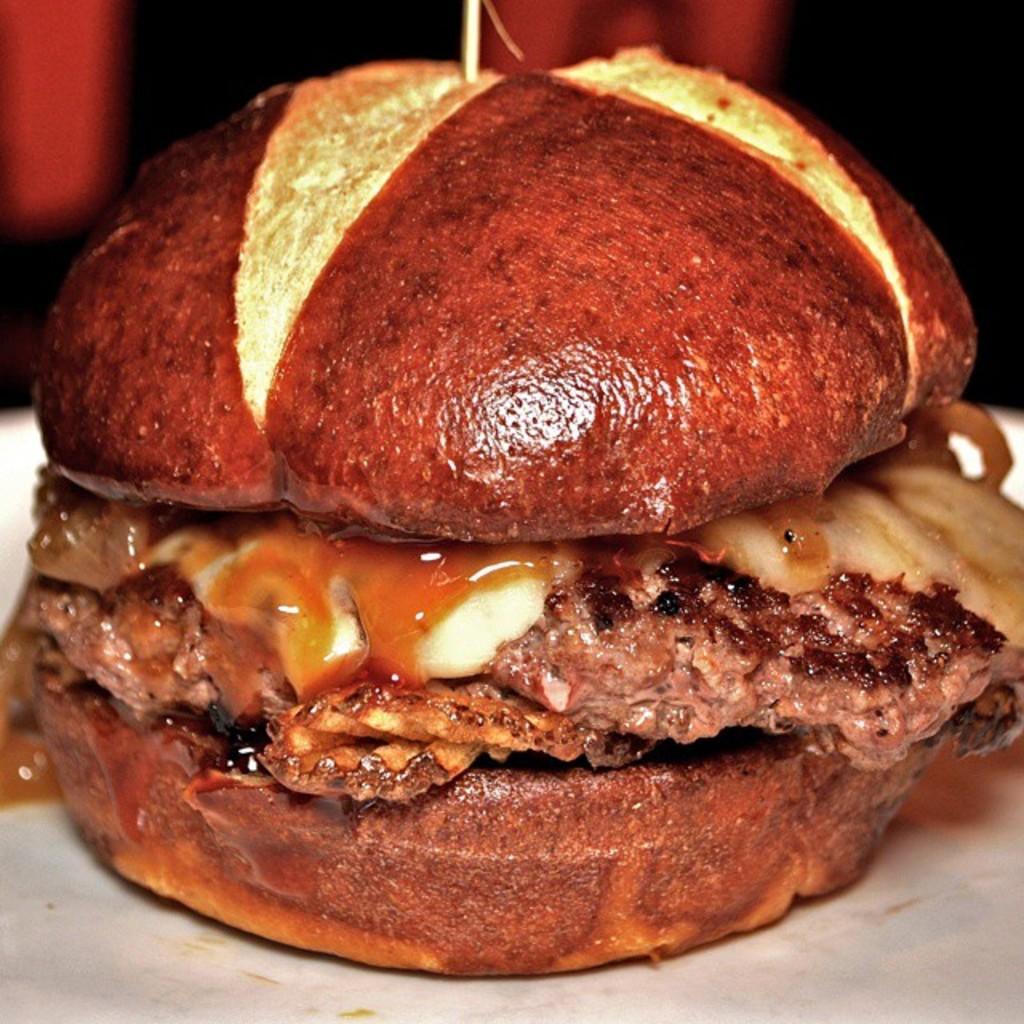Please provide a concise description of this image. A picture of a burger. Background it is blur. Burger is kept on this white surface. 